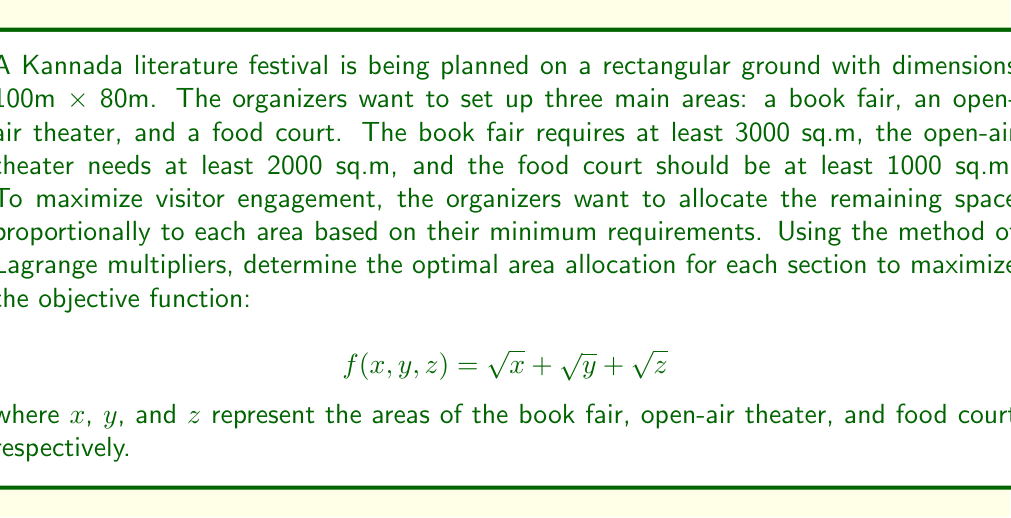Show me your answer to this math problem. Let's approach this problem step by step using the method of Lagrange multipliers:

1) First, we need to set up our constraints:
   - Total area constraint: $x + y + z = 8000$ (100m * 80m = 8000 sq.m)
   - Minimum area constraints: $x \geq 3000$, $y \geq 2000$, $z \geq 1000$

2) The remaining area to be distributed proportionally is 2000 sq.m (8000 - 3000 - 2000 - 1000).

3) Let's define the proportions:
   $p_1 = \frac{3000}{6000} = \frac{1}{2}$, $p_2 = \frac{2000}{6000} = \frac{1}{3}$, $p_3 = \frac{1000}{6000} = \frac{1}{6}$

4) Now we can express $x$, $y$, and $z$ in terms of these proportions:
   $x = 3000 + \frac{1}{2}t$, $y = 2000 + \frac{1}{3}t$, $z = 1000 + \frac{1}{6}t$
   where $t$ is the additional area to be distributed.

5) Our objective function becomes:
   $$ f(t) = \sqrt{3000 + \frac{1}{2}t} + \sqrt{2000 + \frac{1}{3}t} + \sqrt{1000 + \frac{1}{6}t} $$

6) To find the maximum, we differentiate $f(t)$ and set it to zero:
   $$ f'(t) = \frac{1}{4\sqrt{3000 + \frac{1}{2}t}} + \frac{1}{6\sqrt{2000 + \frac{1}{3}t}} + \frac{1}{12\sqrt{1000 + \frac{1}{6}t}} = 0 $$

7) This equation is complex to solve analytically, so we use numerical methods to find $t \approx 2000$.

8) Substituting this back into our expressions for $x$, $y$, and $z$:
   $x \approx 4000$, $y \approx 2667$, $z \approx 1333$

9) We can verify that these values satisfy our constraints:
   $4000 + 2667 + 1333 = 8000$
   $4000 > 3000$, $2667 > 2000$, $1333 > 1000$
Answer: The optimal area allocation is approximately:
Book fair (x): 4000 sq.m
Open-air theater (y): 2667 sq.m
Food court (z): 1333 sq.m 